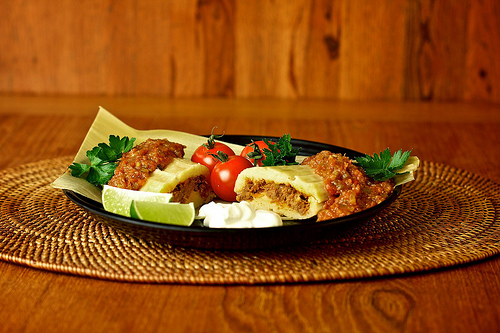<image>
Can you confirm if the placemat is on the enchilada? No. The placemat is not positioned on the enchilada. They may be near each other, but the placemat is not supported by or resting on top of the enchilada. Is there a tomato next to the plate? No. The tomato is not positioned next to the plate. They are located in different areas of the scene. 